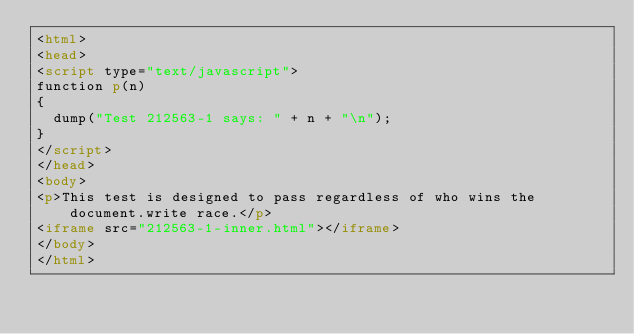<code> <loc_0><loc_0><loc_500><loc_500><_HTML_><html>
<head>
<script type="text/javascript">
function p(n)
{
  dump("Test 212563-1 says: " + n + "\n");
}
</script>
</head>
<body>
<p>This test is designed to pass regardless of who wins the document.write race.</p>
<iframe src="212563-1-inner.html"></iframe>
</body>
</html>
</code> 